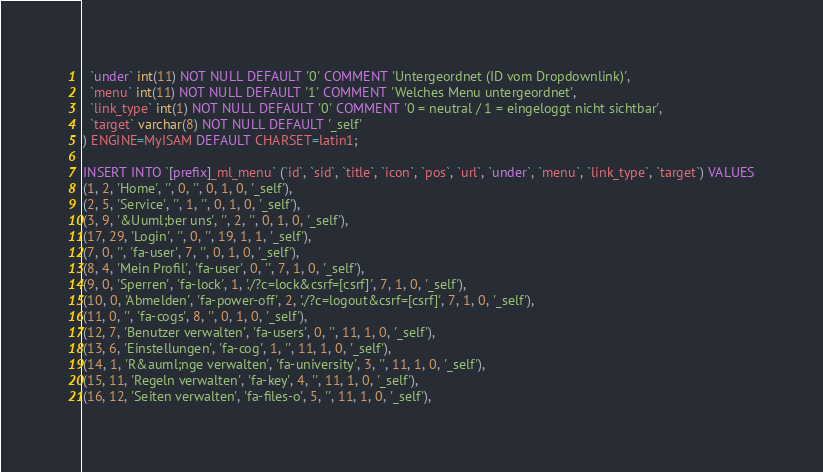Convert code to text. <code><loc_0><loc_0><loc_500><loc_500><_SQL_>  `under` int(11) NOT NULL DEFAULT '0' COMMENT 'Untergeordnet (ID vom Dropdownlink)',
  `menu` int(11) NOT NULL DEFAULT '1' COMMENT 'Welches Menu untergeordnet',
  `link_type` int(1) NOT NULL DEFAULT '0' COMMENT '0 = neutral / 1 = eingeloggt nicht sichtbar',
  `target` varchar(8) NOT NULL DEFAULT '_self'
) ENGINE=MyISAM DEFAULT CHARSET=latin1;

INSERT INTO `[prefix]_ml_menu` (`id`, `sid`, `title`, `icon`, `pos`, `url`, `under`, `menu`, `link_type`, `target`) VALUES
(1, 2, 'Home', '', 0, '', 0, 1, 0, '_self'),
(2, 5, 'Service', '', 1, '', 0, 1, 0, '_self'),
(3, 9, '&Uuml;ber uns', '', 2, '', 0, 1, 0, '_self'),
(17, 29, 'Login', '', 0, '', 19, 1, 1, '_self'),
(7, 0, '', 'fa-user', 7, '', 0, 1, 0, '_self'),
(8, 4, 'Mein Profil', 'fa-user', 0, '', 7, 1, 0, '_self'),
(9, 0, 'Sperren', 'fa-lock', 1, './?c=lock&csrf=[csrf]', 7, 1, 0, '_self'),
(10, 0, 'Abmelden', 'fa-power-off', 2, './?c=logout&csrf=[csrf]', 7, 1, 0, '_self'),
(11, 0, '', 'fa-cogs', 8, '', 0, 1, 0, '_self'),
(12, 7, 'Benutzer verwalten', 'fa-users', 0, '', 11, 1, 0, '_self'),
(13, 6, 'Einstellungen', 'fa-cog', 1, '', 11, 1, 0, '_self'),
(14, 1, 'R&auml;nge verwalten', 'fa-university', 3, '', 11, 1, 0, '_self'),
(15, 11, 'Regeln verwalten', 'fa-key', 4, '', 11, 1, 0, '_self'),
(16, 12, 'Seiten verwalten', 'fa-files-o', 5, '', 11, 1, 0, '_self'),</code> 